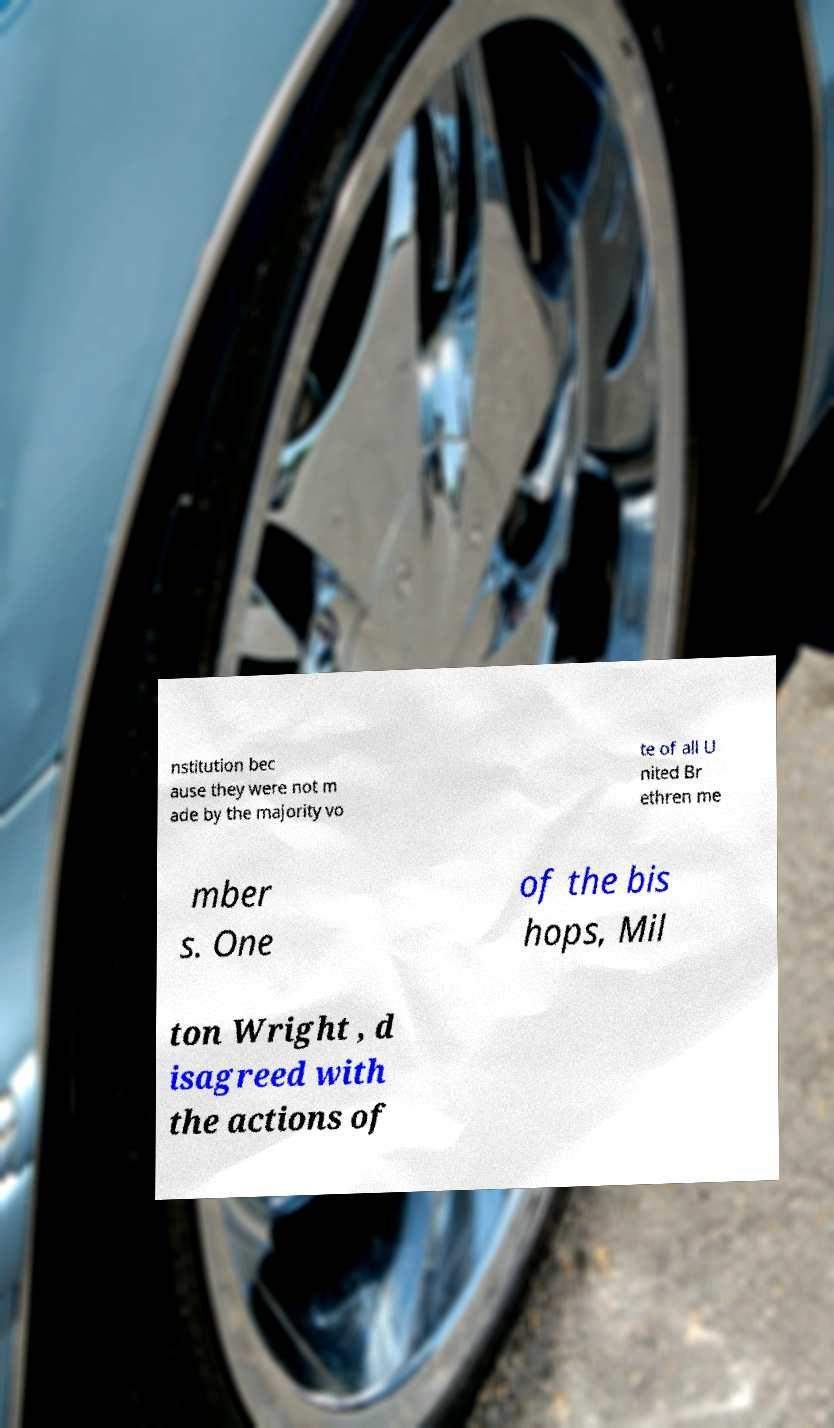Please identify and transcribe the text found in this image. nstitution bec ause they were not m ade by the majority vo te of all U nited Br ethren me mber s. One of the bis hops, Mil ton Wright , d isagreed with the actions of 